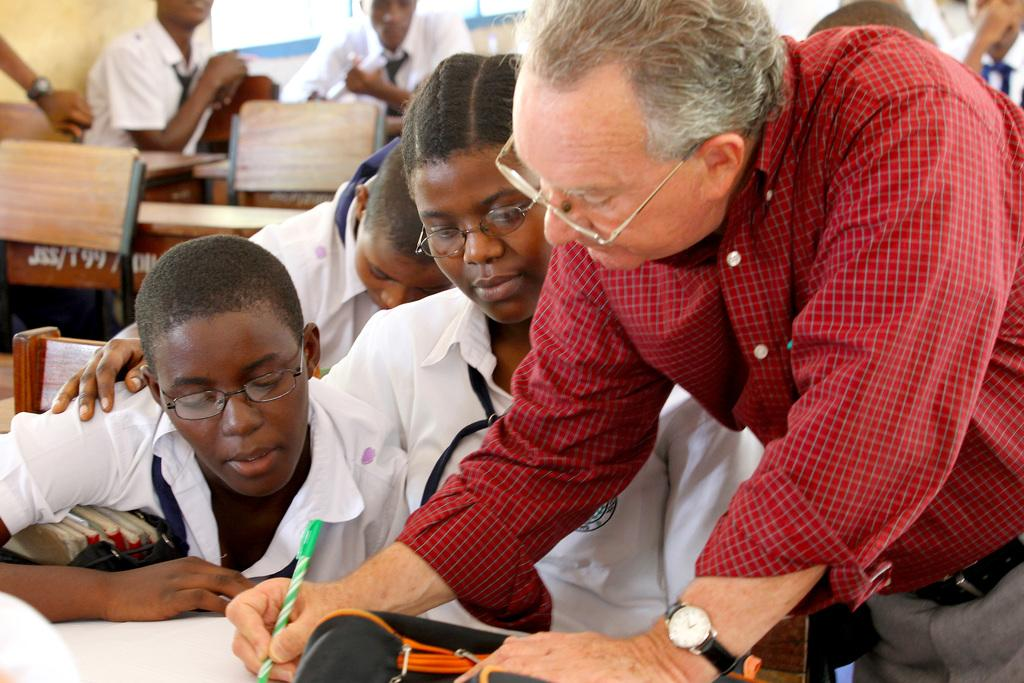What is the man in the image doing? The man is standing in the image. What is the man holding in his hand? The man is holding a pen and a pouch in his hand. What are the other people in the image doing? The other people in the image are sitting on benches. Can you see the man's toes in the image? There is no indication of the man's toes in the image, as he is standing and holding items in his hands. 